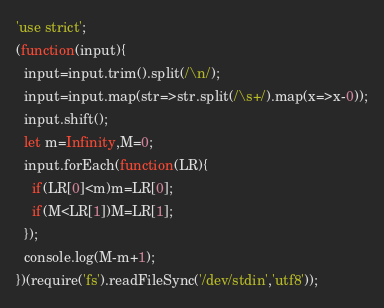Convert code to text. <code><loc_0><loc_0><loc_500><loc_500><_JavaScript_>'use strict';
(function(input){
  input=input.trim().split(/\n/);
  input=input.map(str=>str.split(/\s+/).map(x=>x-0));
  input.shift();
  let m=Infinity,M=0;
  input.forEach(function(LR){
    if(LR[0]<m)m=LR[0];
    if(M<LR[1])M=LR[1];
  });
  console.log(M-m+1);
})(require('fs').readFileSync('/dev/stdin','utf8'));</code> 